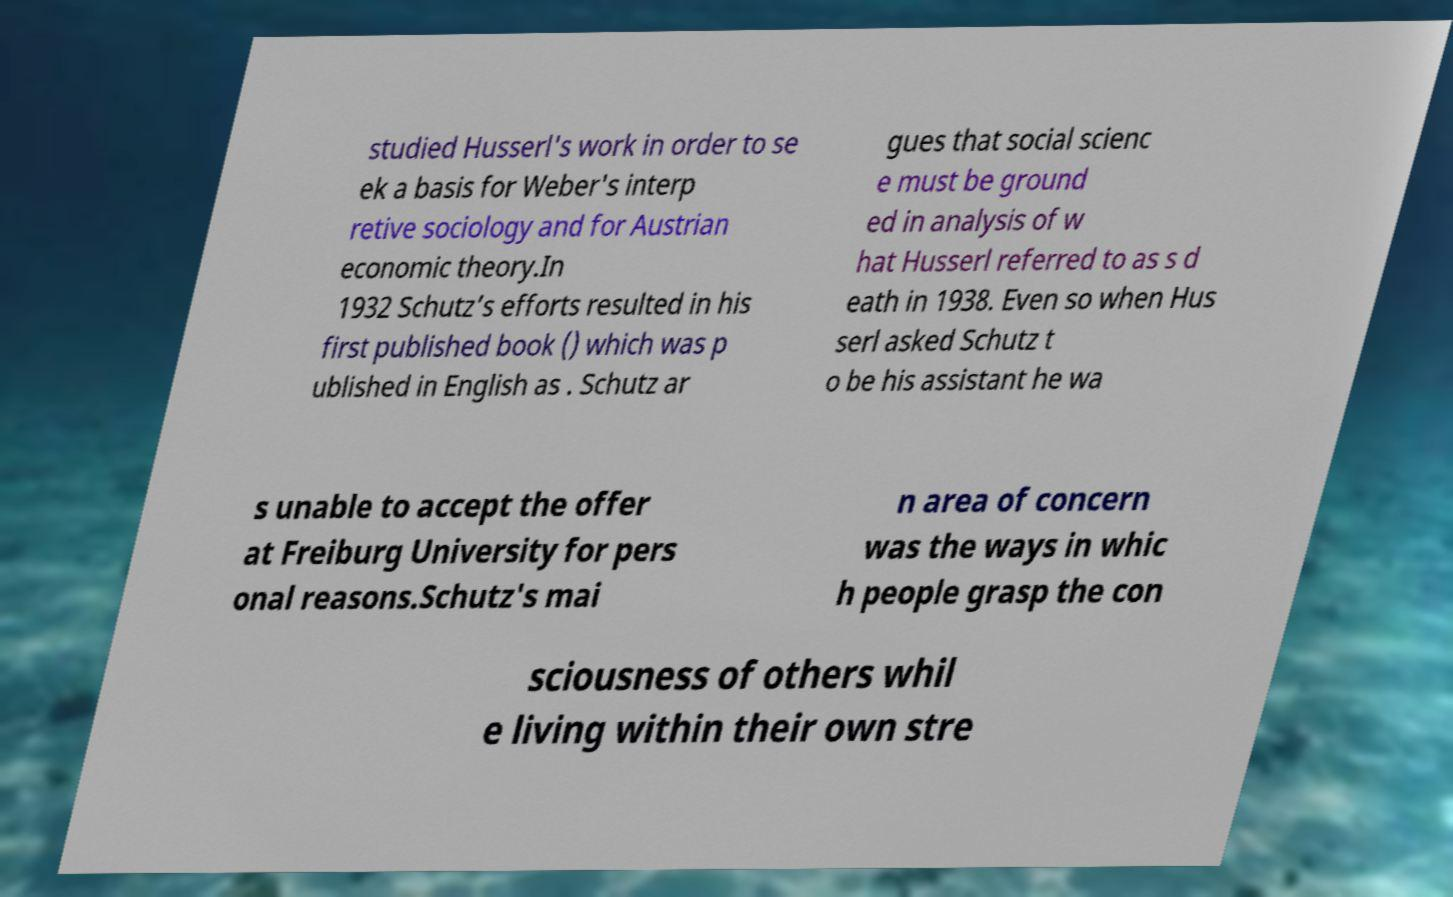Please identify and transcribe the text found in this image. studied Husserl's work in order to se ek a basis for Weber's interp retive sociology and for Austrian economic theory.In 1932 Schutz’s efforts resulted in his first published book () which was p ublished in English as . Schutz ar gues that social scienc e must be ground ed in analysis of w hat Husserl referred to as s d eath in 1938. Even so when Hus serl asked Schutz t o be his assistant he wa s unable to accept the offer at Freiburg University for pers onal reasons.Schutz's mai n area of concern was the ways in whic h people grasp the con sciousness of others whil e living within their own stre 